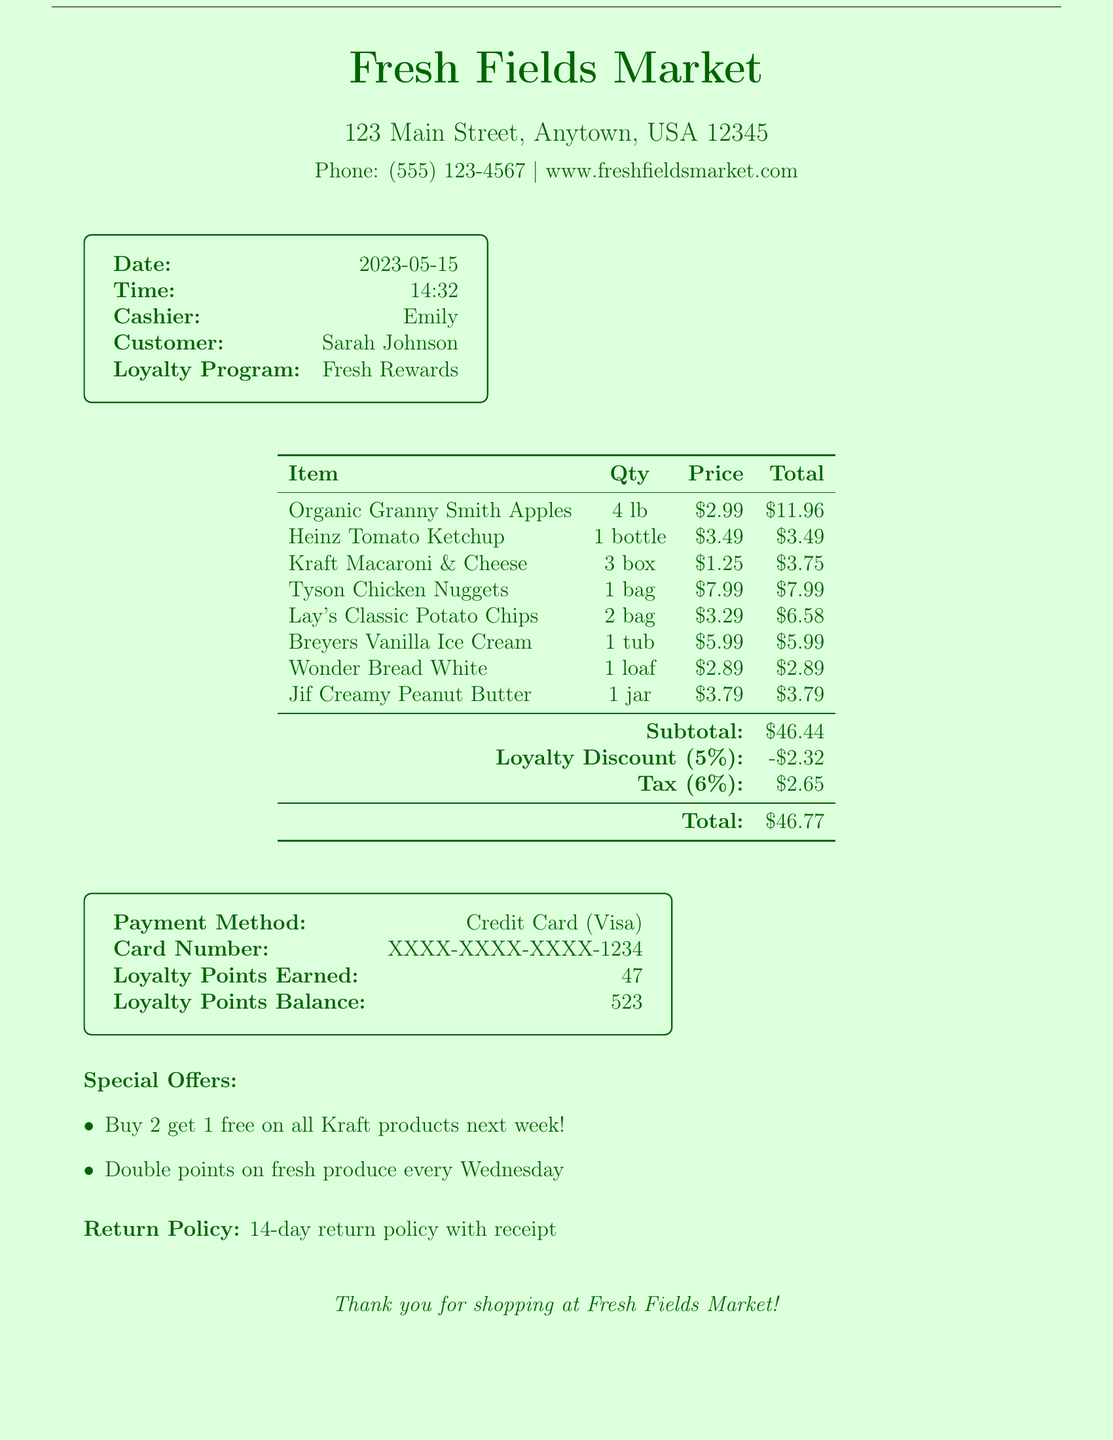What is the store name? The store name is prominently displayed at the top of the receipt.
Answer: Fresh Fields Market What is the date of the transaction? The date of the transaction is listed in the receipt details.
Answer: 2023-05-15 Who was the cashier? The cashier's name is mentioned in the receipt for customer reference.
Answer: Emily What was the quantity of Organic Granny Smith Apples purchased? The quantity for each item is specified in the list of purchased items.
Answer: 4 lb What is the subtotal amount? The subtotal amount is the total of items before discounts and tax, indicated near the bottom of the item list.
Answer: $46.44 What percentage is the loyalty discount? The loyalty discount percentage is clearly stated in the receipt details.
Answer: 5% How much tax was added? The tax amount is shown clearly below the subtotal and loyalty discount.
Answer: $2.65 What is the total amount paid? The total is the final amount payable after all discounts and taxes, listed at the end of the receipt.
Answer: $46.77 What payment method was used? The payment method is mentioned in the receipt, indicating how the transaction was completed.
Answer: Credit Card How many loyalty points were earned from this purchase? The earned loyalty points are noted in the summary of the transaction.
Answer: 47 